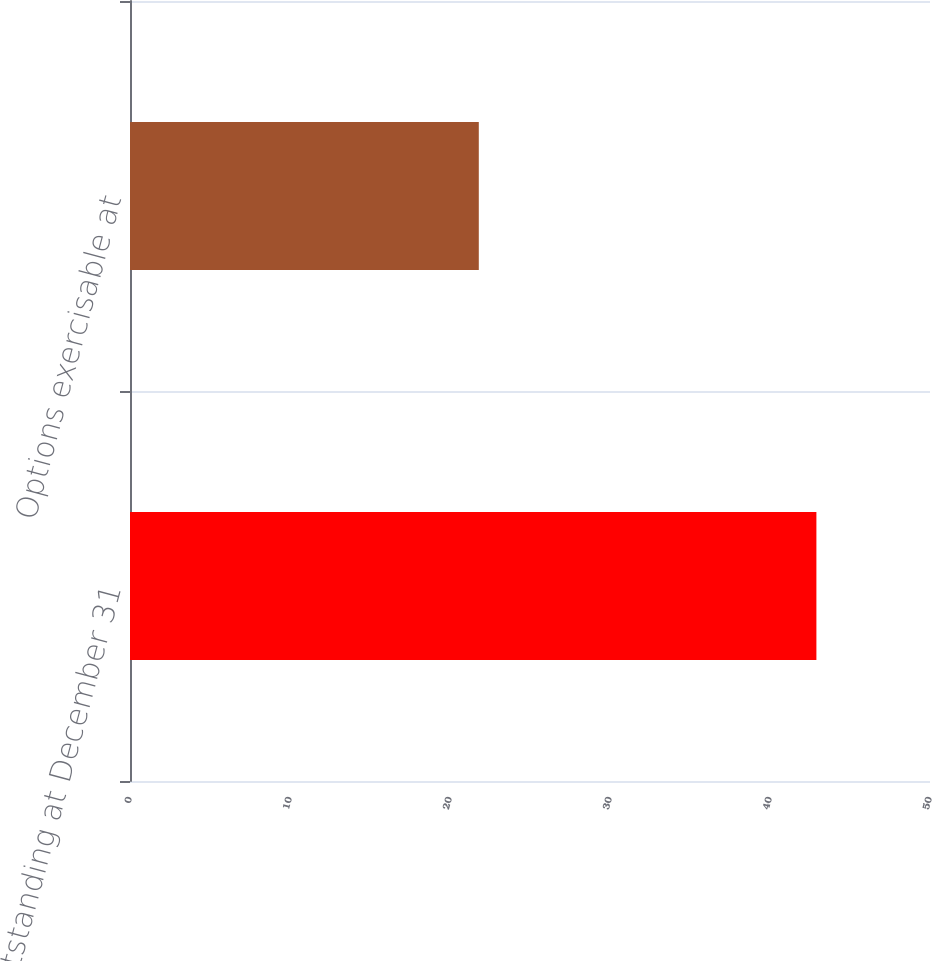Convert chart to OTSL. <chart><loc_0><loc_0><loc_500><loc_500><bar_chart><fcel>Outstanding at December 31<fcel>Options exercisable at<nl><fcel>42.9<fcel>21.8<nl></chart> 